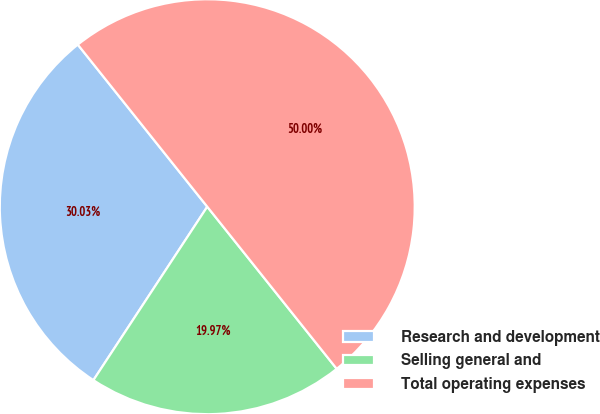<chart> <loc_0><loc_0><loc_500><loc_500><pie_chart><fcel>Research and development<fcel>Selling general and<fcel>Total operating expenses<nl><fcel>30.03%<fcel>19.97%<fcel>50.0%<nl></chart> 